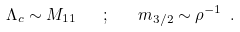Convert formula to latex. <formula><loc_0><loc_0><loc_500><loc_500>\Lambda _ { c } \sim M _ { 1 1 } \quad ; \quad m _ { 3 / 2 } \sim \rho ^ { - 1 } \ .</formula> 